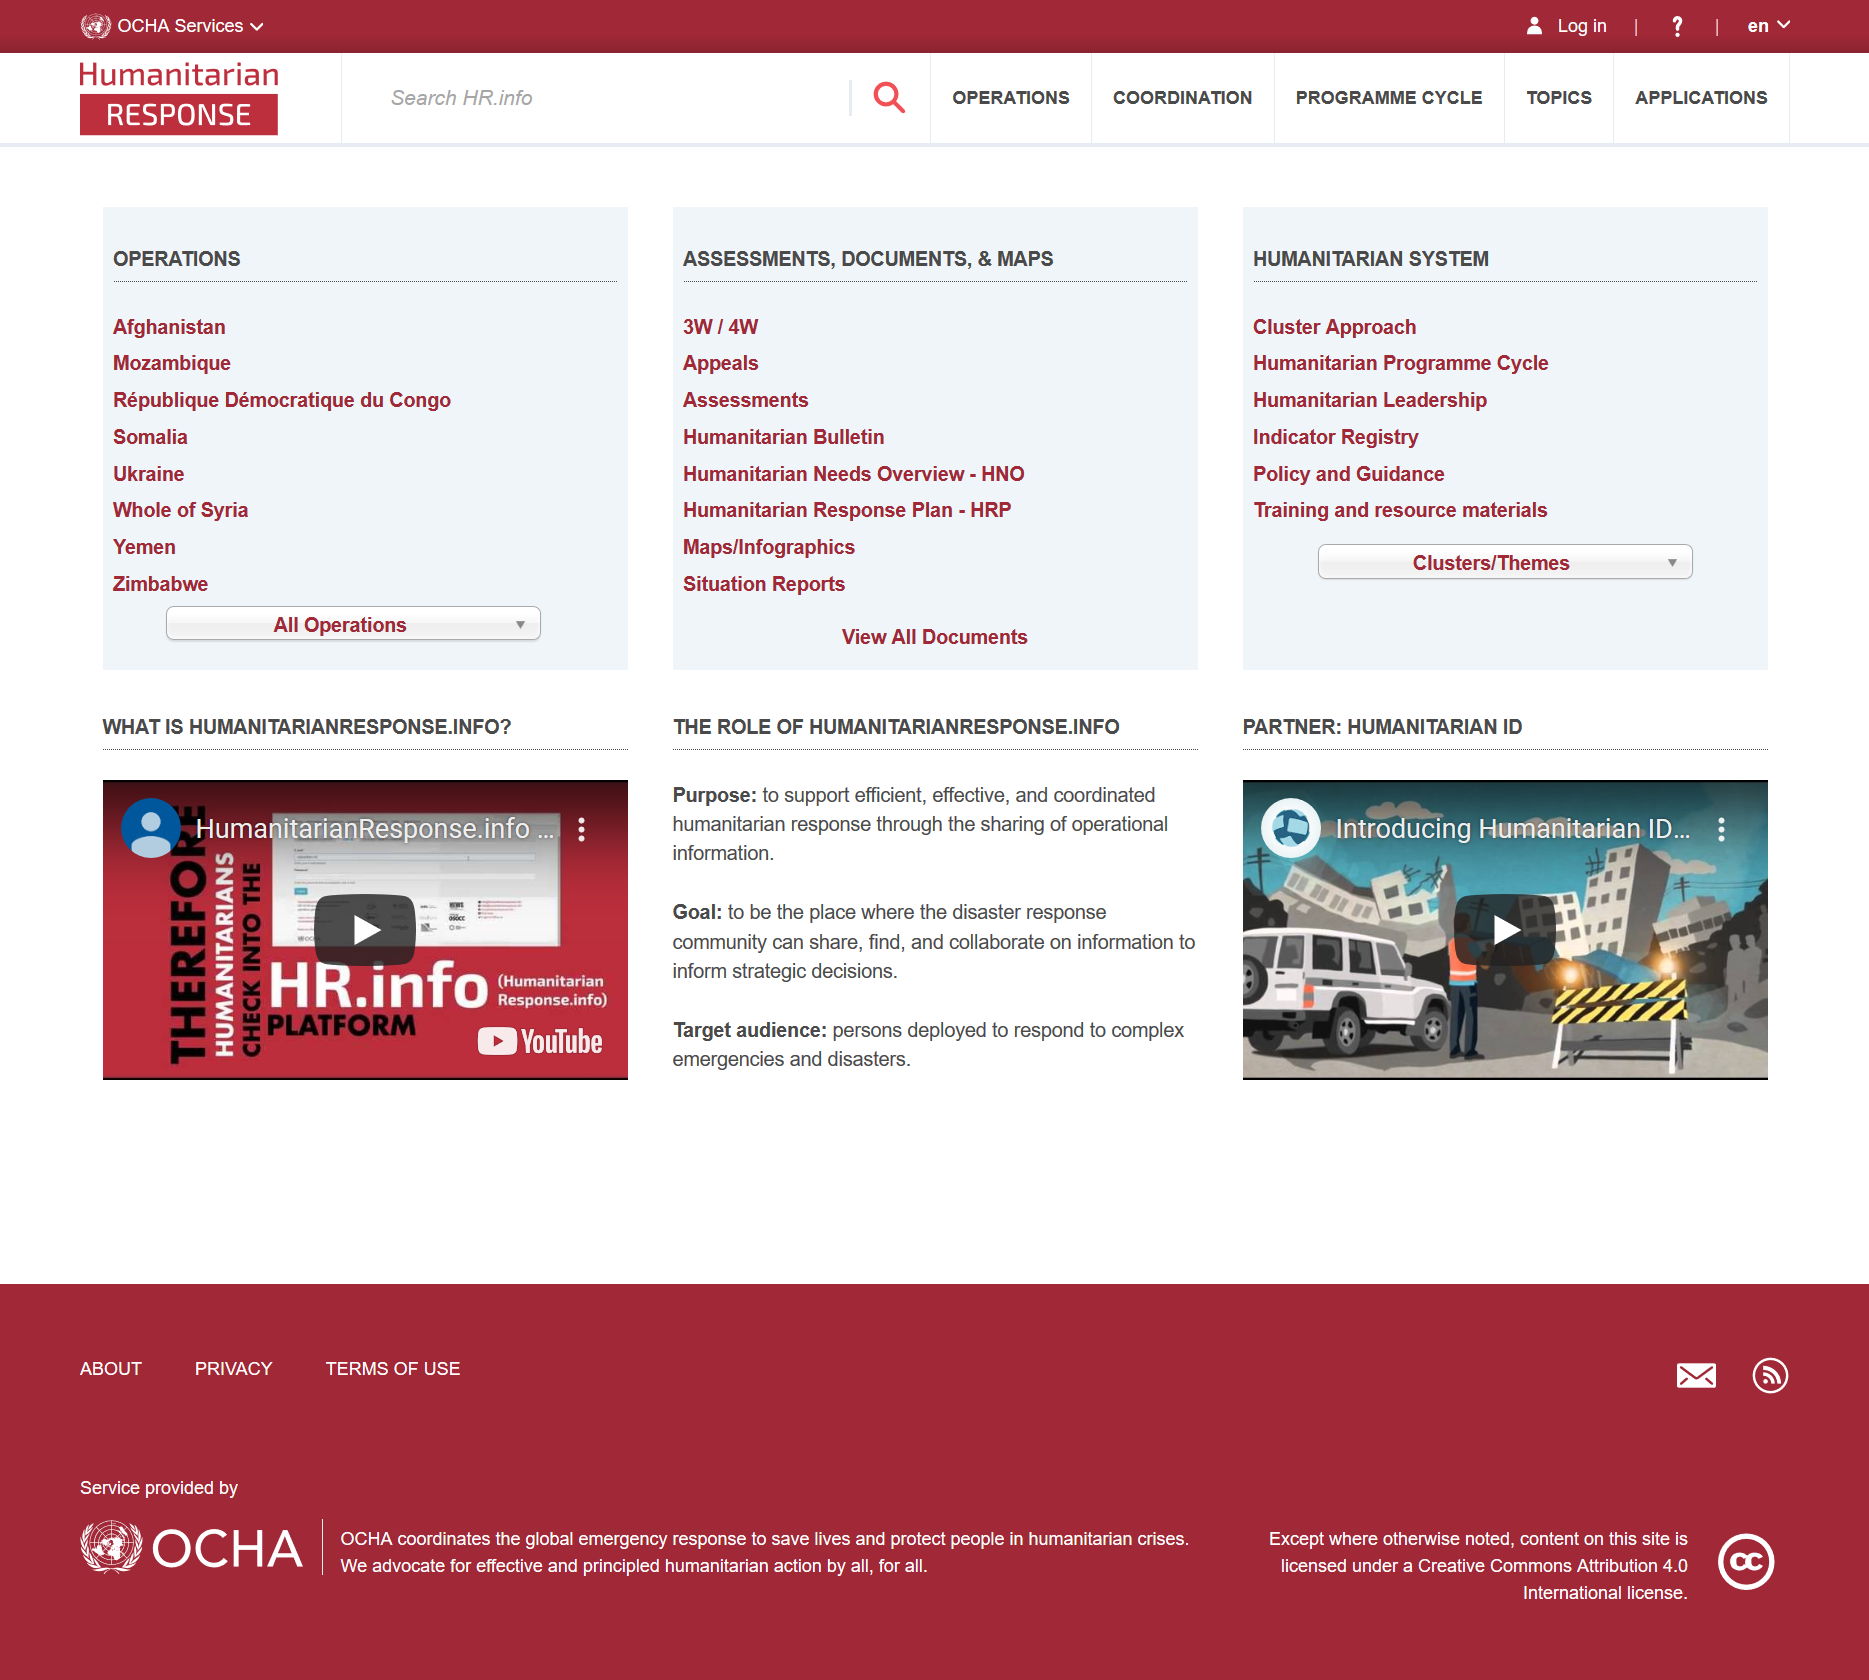Specify some key components in this picture. The goal of humanitarianresponse.info is to serve as a platform for the disaster response community to share, discover, and collaborate on information in order to inform strategic decision-making. The target audience of humanitarianresponse.info includes individuals deployed to respond to complex emergencies and disasters. The website humanitarianresponse.info serves the purpose of facilitating efficient, effective, and coordinated humanitarian response by providing operational information sharing. 